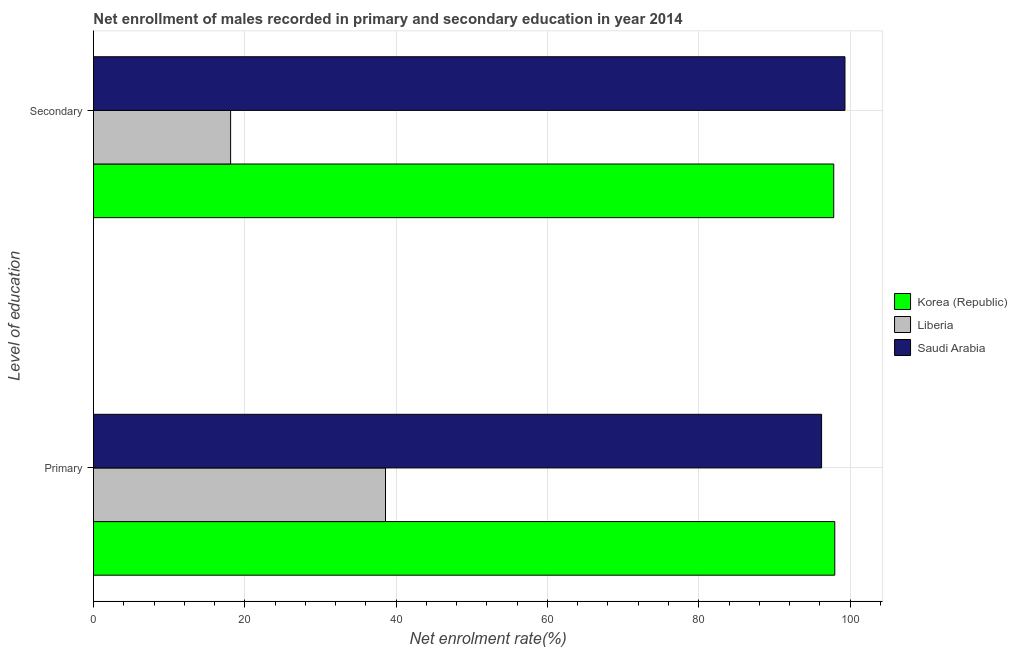How many different coloured bars are there?
Provide a succinct answer. 3. How many bars are there on the 1st tick from the top?
Provide a succinct answer. 3. How many bars are there on the 2nd tick from the bottom?
Your answer should be compact. 3. What is the label of the 2nd group of bars from the top?
Offer a very short reply. Primary. What is the enrollment rate in primary education in Saudi Arabia?
Make the answer very short. 96.24. Across all countries, what is the maximum enrollment rate in primary education?
Your response must be concise. 97.98. Across all countries, what is the minimum enrollment rate in primary education?
Give a very brief answer. 38.6. In which country was the enrollment rate in primary education minimum?
Ensure brevity in your answer.  Liberia. What is the total enrollment rate in secondary education in the graph?
Provide a succinct answer. 215.29. What is the difference between the enrollment rate in secondary education in Korea (Republic) and that in Saudi Arabia?
Provide a short and direct response. -1.48. What is the difference between the enrollment rate in secondary education in Liberia and the enrollment rate in primary education in Korea (Republic)?
Offer a very short reply. -79.85. What is the average enrollment rate in secondary education per country?
Your answer should be compact. 71.76. What is the difference between the enrollment rate in primary education and enrollment rate in secondary education in Liberia?
Offer a terse response. 20.47. What is the ratio of the enrollment rate in primary education in Saudi Arabia to that in Korea (Republic)?
Give a very brief answer. 0.98. What does the 1st bar from the top in Secondary represents?
Provide a succinct answer. Saudi Arabia. What does the 3rd bar from the bottom in Secondary represents?
Your answer should be compact. Saudi Arabia. How many bars are there?
Your response must be concise. 6. How many countries are there in the graph?
Provide a succinct answer. 3. What is the difference between two consecutive major ticks on the X-axis?
Your answer should be very brief. 20. Are the values on the major ticks of X-axis written in scientific E-notation?
Your answer should be compact. No. Does the graph contain any zero values?
Offer a terse response. No. Does the graph contain grids?
Give a very brief answer. Yes. How are the legend labels stacked?
Offer a terse response. Vertical. What is the title of the graph?
Ensure brevity in your answer.  Net enrollment of males recorded in primary and secondary education in year 2014. What is the label or title of the X-axis?
Ensure brevity in your answer.  Net enrolment rate(%). What is the label or title of the Y-axis?
Give a very brief answer. Level of education. What is the Net enrolment rate(%) in Korea (Republic) in Primary?
Your response must be concise. 97.98. What is the Net enrolment rate(%) of Liberia in Primary?
Your answer should be compact. 38.6. What is the Net enrolment rate(%) in Saudi Arabia in Primary?
Keep it short and to the point. 96.24. What is the Net enrolment rate(%) in Korea (Republic) in Secondary?
Ensure brevity in your answer.  97.84. What is the Net enrolment rate(%) in Liberia in Secondary?
Your answer should be very brief. 18.13. What is the Net enrolment rate(%) of Saudi Arabia in Secondary?
Keep it short and to the point. 99.32. Across all Level of education, what is the maximum Net enrolment rate(%) in Korea (Republic)?
Keep it short and to the point. 97.98. Across all Level of education, what is the maximum Net enrolment rate(%) of Liberia?
Make the answer very short. 38.6. Across all Level of education, what is the maximum Net enrolment rate(%) of Saudi Arabia?
Provide a short and direct response. 99.32. Across all Level of education, what is the minimum Net enrolment rate(%) in Korea (Republic)?
Offer a very short reply. 97.84. Across all Level of education, what is the minimum Net enrolment rate(%) of Liberia?
Your answer should be very brief. 18.13. Across all Level of education, what is the minimum Net enrolment rate(%) of Saudi Arabia?
Provide a short and direct response. 96.24. What is the total Net enrolment rate(%) in Korea (Republic) in the graph?
Provide a short and direct response. 195.82. What is the total Net enrolment rate(%) of Liberia in the graph?
Keep it short and to the point. 56.72. What is the total Net enrolment rate(%) in Saudi Arabia in the graph?
Ensure brevity in your answer.  195.56. What is the difference between the Net enrolment rate(%) in Korea (Republic) in Primary and that in Secondary?
Offer a very short reply. 0.14. What is the difference between the Net enrolment rate(%) of Liberia in Primary and that in Secondary?
Provide a short and direct response. 20.47. What is the difference between the Net enrolment rate(%) of Saudi Arabia in Primary and that in Secondary?
Offer a very short reply. -3.09. What is the difference between the Net enrolment rate(%) in Korea (Republic) in Primary and the Net enrolment rate(%) in Liberia in Secondary?
Give a very brief answer. 79.85. What is the difference between the Net enrolment rate(%) of Korea (Republic) in Primary and the Net enrolment rate(%) of Saudi Arabia in Secondary?
Provide a succinct answer. -1.35. What is the difference between the Net enrolment rate(%) of Liberia in Primary and the Net enrolment rate(%) of Saudi Arabia in Secondary?
Your answer should be very brief. -60.73. What is the average Net enrolment rate(%) of Korea (Republic) per Level of education?
Make the answer very short. 97.91. What is the average Net enrolment rate(%) in Liberia per Level of education?
Offer a terse response. 28.36. What is the average Net enrolment rate(%) of Saudi Arabia per Level of education?
Offer a very short reply. 97.78. What is the difference between the Net enrolment rate(%) in Korea (Republic) and Net enrolment rate(%) in Liberia in Primary?
Your answer should be very brief. 59.38. What is the difference between the Net enrolment rate(%) in Korea (Republic) and Net enrolment rate(%) in Saudi Arabia in Primary?
Provide a short and direct response. 1.74. What is the difference between the Net enrolment rate(%) of Liberia and Net enrolment rate(%) of Saudi Arabia in Primary?
Offer a terse response. -57.64. What is the difference between the Net enrolment rate(%) of Korea (Republic) and Net enrolment rate(%) of Liberia in Secondary?
Provide a succinct answer. 79.71. What is the difference between the Net enrolment rate(%) of Korea (Republic) and Net enrolment rate(%) of Saudi Arabia in Secondary?
Your response must be concise. -1.48. What is the difference between the Net enrolment rate(%) in Liberia and Net enrolment rate(%) in Saudi Arabia in Secondary?
Your response must be concise. -81.2. What is the ratio of the Net enrolment rate(%) in Liberia in Primary to that in Secondary?
Provide a succinct answer. 2.13. What is the ratio of the Net enrolment rate(%) of Saudi Arabia in Primary to that in Secondary?
Give a very brief answer. 0.97. What is the difference between the highest and the second highest Net enrolment rate(%) in Korea (Republic)?
Keep it short and to the point. 0.14. What is the difference between the highest and the second highest Net enrolment rate(%) in Liberia?
Make the answer very short. 20.47. What is the difference between the highest and the second highest Net enrolment rate(%) of Saudi Arabia?
Your answer should be compact. 3.09. What is the difference between the highest and the lowest Net enrolment rate(%) in Korea (Republic)?
Your answer should be very brief. 0.14. What is the difference between the highest and the lowest Net enrolment rate(%) in Liberia?
Provide a short and direct response. 20.47. What is the difference between the highest and the lowest Net enrolment rate(%) of Saudi Arabia?
Provide a succinct answer. 3.09. 